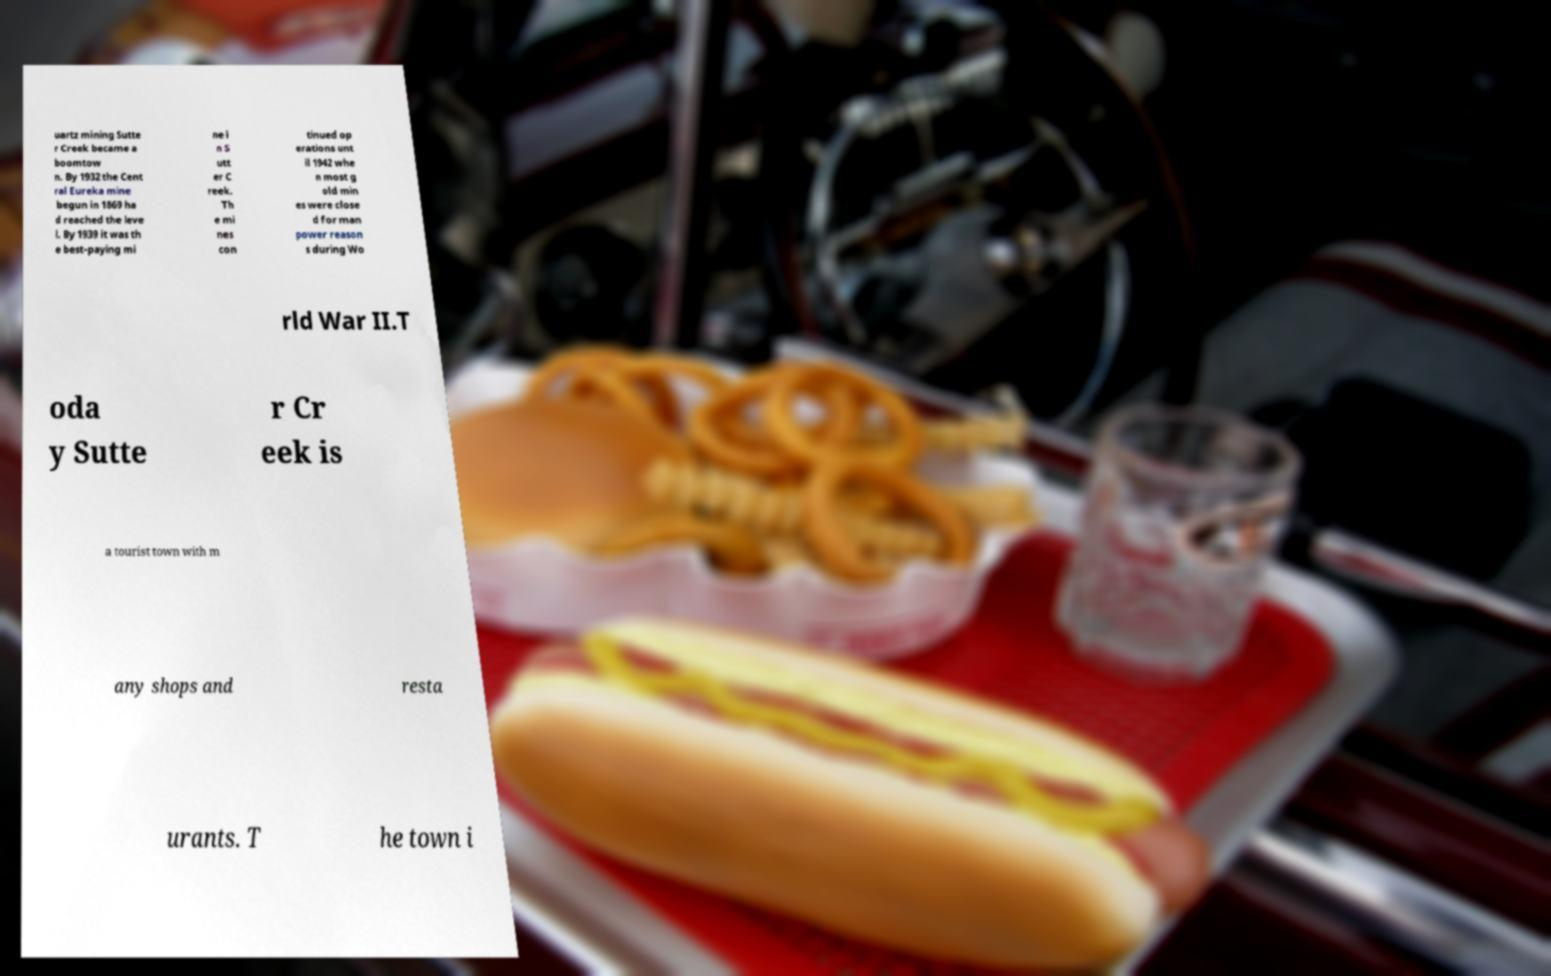Can you read and provide the text displayed in the image?This photo seems to have some interesting text. Can you extract and type it out for me? uartz mining Sutte r Creek became a boomtow n. By 1932 the Cent ral Eureka mine begun in 1869 ha d reached the leve l. By 1939 it was th e best-paying mi ne i n S utt er C reek. Th e mi nes con tinued op erations unt il 1942 whe n most g old min es were close d for man power reason s during Wo rld War II.T oda y Sutte r Cr eek is a tourist town with m any shops and resta urants. T he town i 